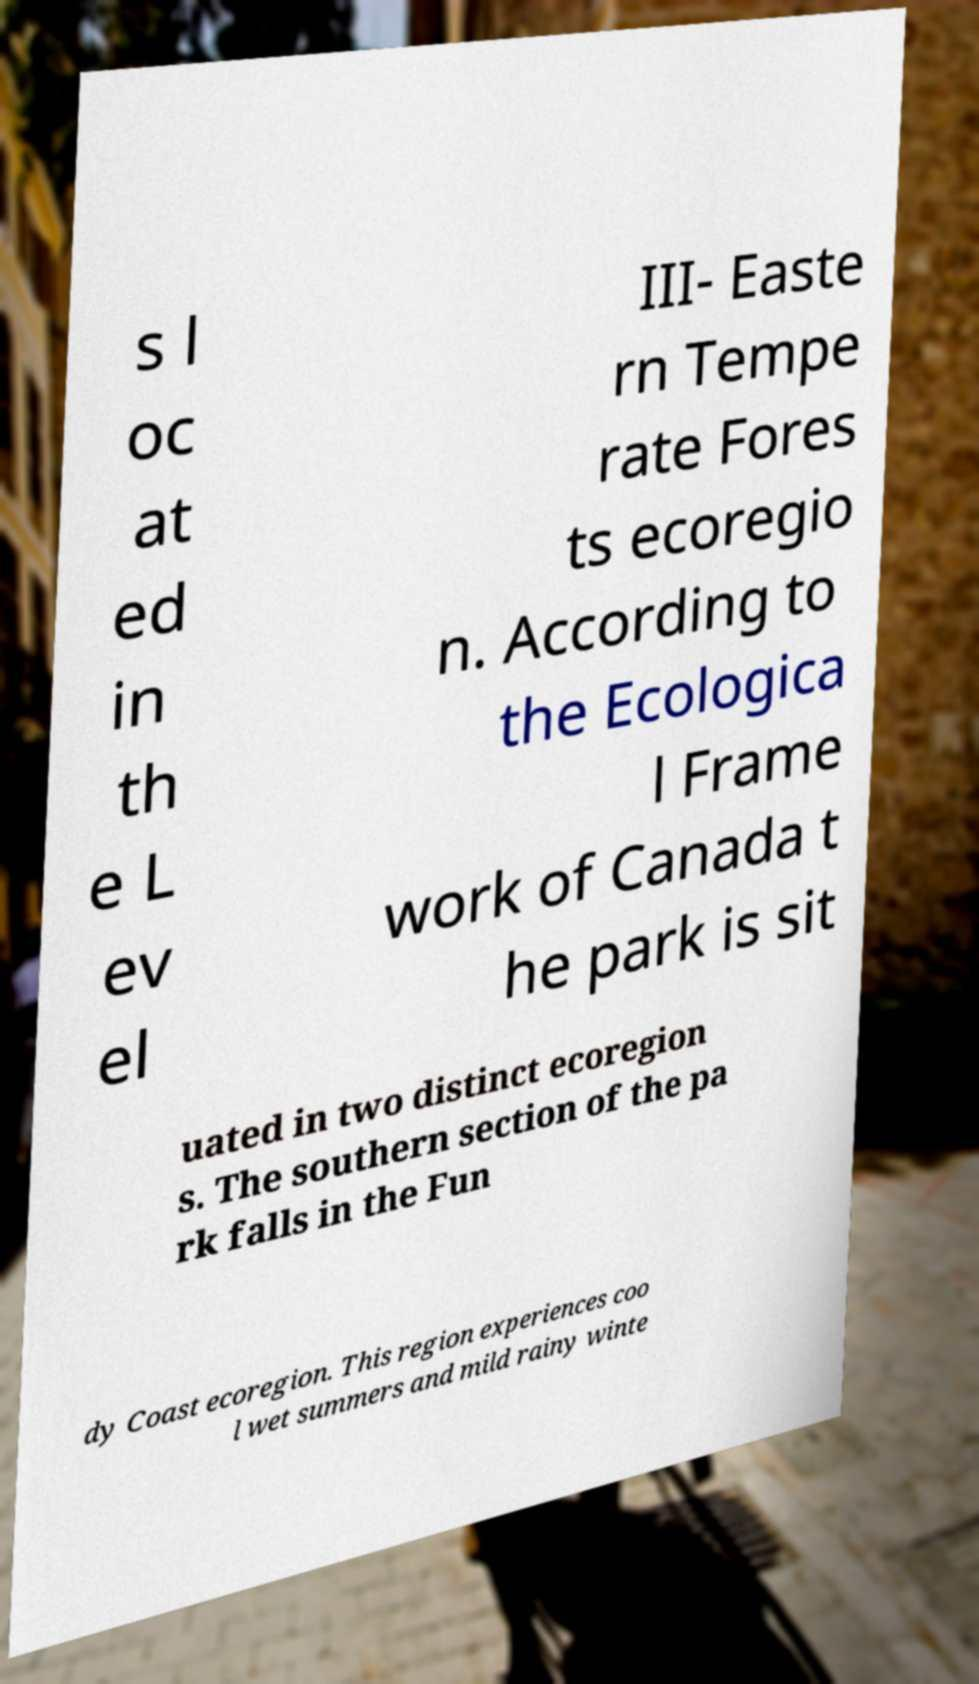What messages or text are displayed in this image? I need them in a readable, typed format. s l oc at ed in th e L ev el III- Easte rn Tempe rate Fores ts ecoregio n. According to the Ecologica l Frame work of Canada t he park is sit uated in two distinct ecoregion s. The southern section of the pa rk falls in the Fun dy Coast ecoregion. This region experiences coo l wet summers and mild rainy winte 